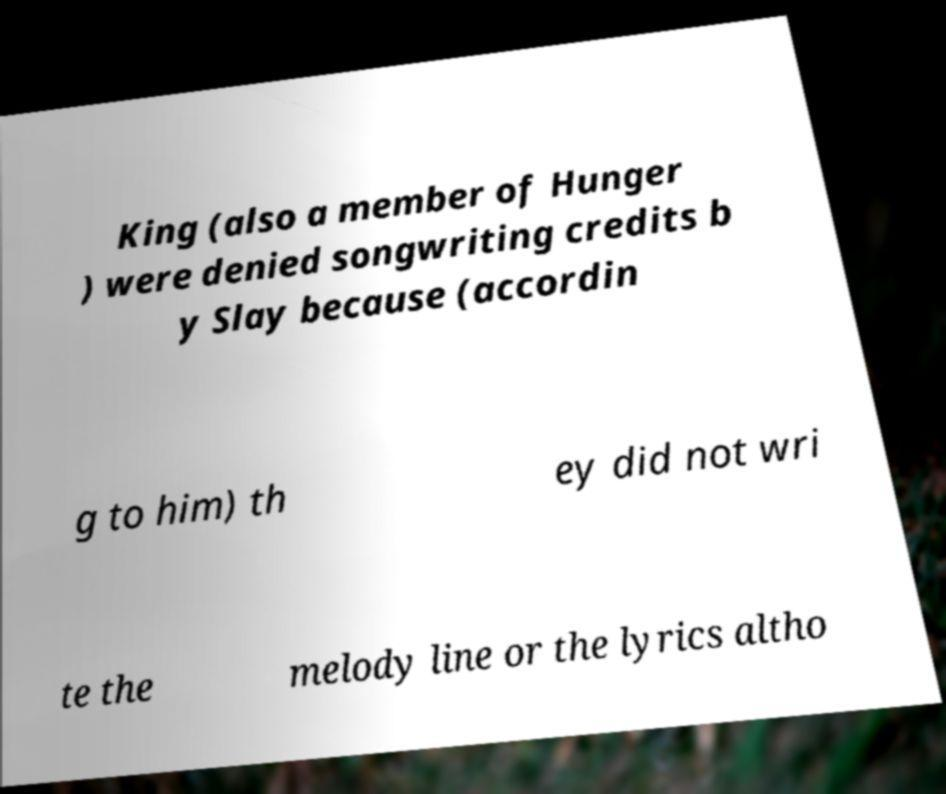Can you accurately transcribe the text from the provided image for me? King (also a member of Hunger ) were denied songwriting credits b y Slay because (accordin g to him) th ey did not wri te the melody line or the lyrics altho 